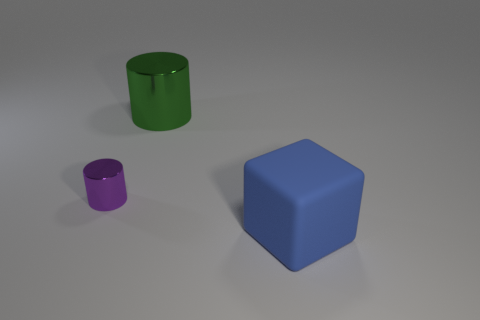Add 3 big brown blocks. How many objects exist? 6 Subtract all cylinders. How many objects are left? 1 Subtract 0 blue cylinders. How many objects are left? 3 Subtract all small brown matte balls. Subtract all tiny things. How many objects are left? 2 Add 3 green shiny things. How many green shiny things are left? 4 Add 2 green metal objects. How many green metal objects exist? 3 